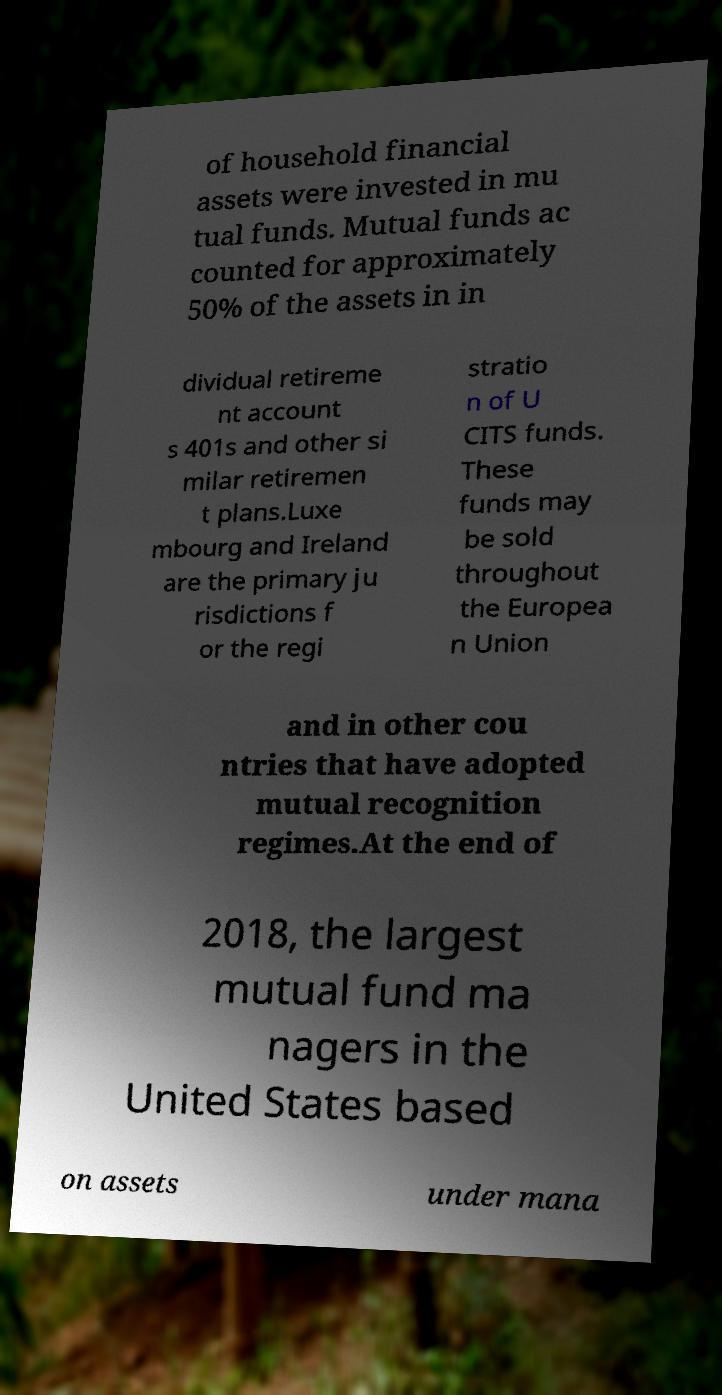What messages or text are displayed in this image? I need them in a readable, typed format. of household financial assets were invested in mu tual funds. Mutual funds ac counted for approximately 50% of the assets in in dividual retireme nt account s 401s and other si milar retiremen t plans.Luxe mbourg and Ireland are the primary ju risdictions f or the regi stratio n of U CITS funds. These funds may be sold throughout the Europea n Union and in other cou ntries that have adopted mutual recognition regimes.At the end of 2018, the largest mutual fund ma nagers in the United States based on assets under mana 